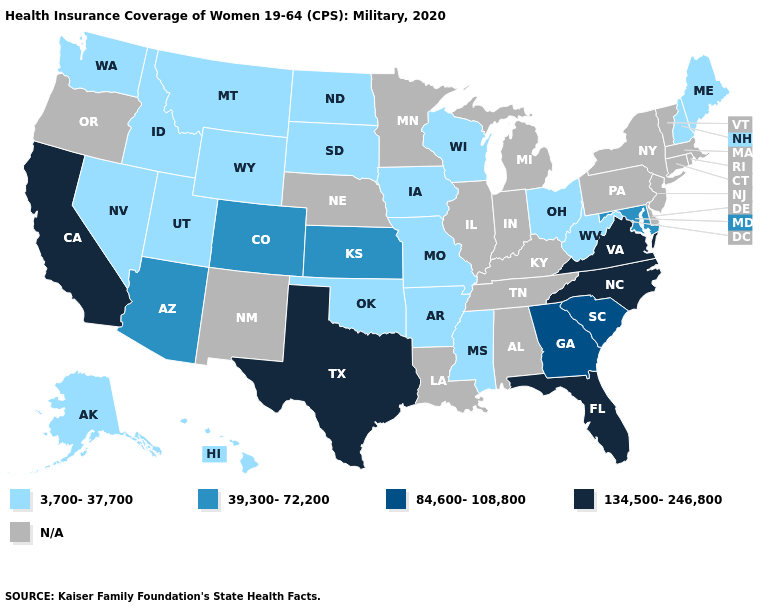Name the states that have a value in the range 39,300-72,200?
Write a very short answer. Arizona, Colorado, Kansas, Maryland. Does Kansas have the highest value in the MidWest?
Give a very brief answer. Yes. Does the first symbol in the legend represent the smallest category?
Quick response, please. Yes. Among the states that border Kansas , does Missouri have the lowest value?
Keep it brief. Yes. Name the states that have a value in the range 39,300-72,200?
Keep it brief. Arizona, Colorado, Kansas, Maryland. What is the value of Rhode Island?
Write a very short answer. N/A. What is the value of Idaho?
Answer briefly. 3,700-37,700. What is the value of New York?
Be succinct. N/A. Name the states that have a value in the range 3,700-37,700?
Short answer required. Alaska, Arkansas, Hawaii, Idaho, Iowa, Maine, Mississippi, Missouri, Montana, Nevada, New Hampshire, North Dakota, Ohio, Oklahoma, South Dakota, Utah, Washington, West Virginia, Wisconsin, Wyoming. What is the value of Kansas?
Keep it brief. 39,300-72,200. Does the map have missing data?
Keep it brief. Yes. Among the states that border South Dakota , which have the lowest value?
Concise answer only. Iowa, Montana, North Dakota, Wyoming. 